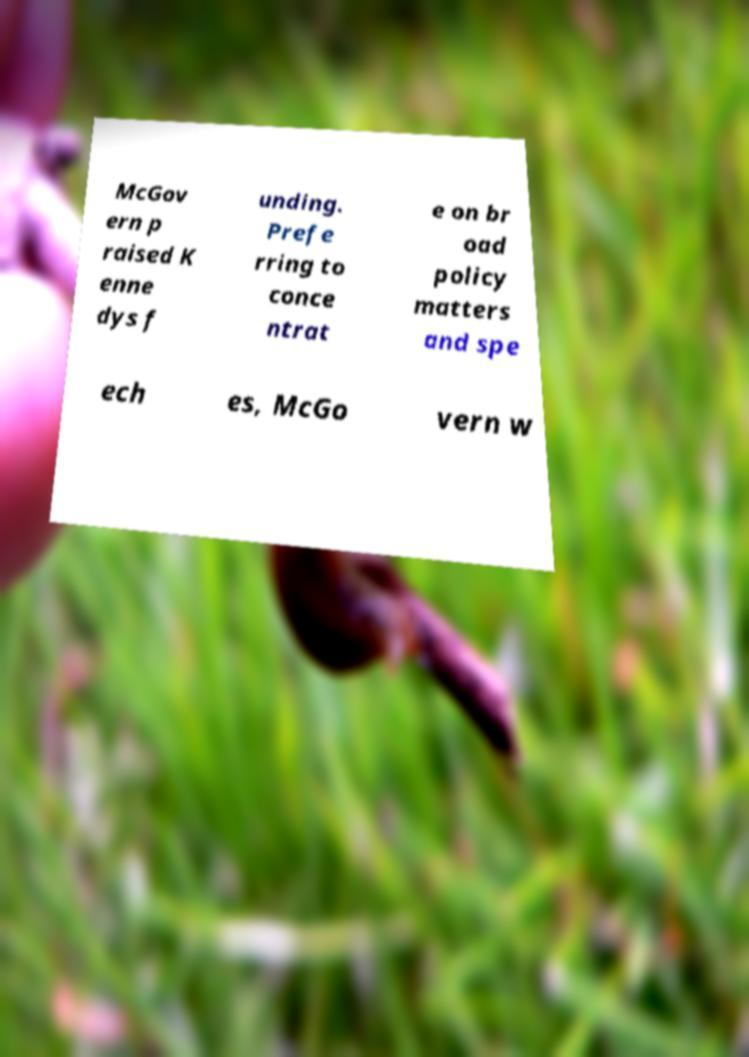For documentation purposes, I need the text within this image transcribed. Could you provide that? McGov ern p raised K enne dys f unding. Prefe rring to conce ntrat e on br oad policy matters and spe ech es, McGo vern w 